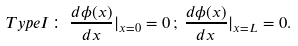<formula> <loc_0><loc_0><loc_500><loc_500>T y p e I \colon \, \frac { d \phi ( x ) } { d x } | _ { x = 0 } = 0 \, ; \, \frac { d \phi ( x ) } { d x } | _ { x = L } = 0 .</formula> 